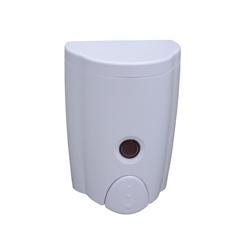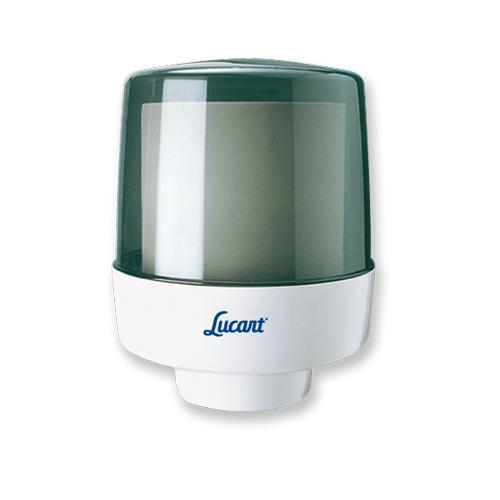The first image is the image on the left, the second image is the image on the right. Considering the images on both sides, is "One image features a white-fronted wall-mount dispenser that is taller than it is wide, and the other image features a dispenser with a white bottom and a shiny transparent convex top." valid? Answer yes or no. Yes. 